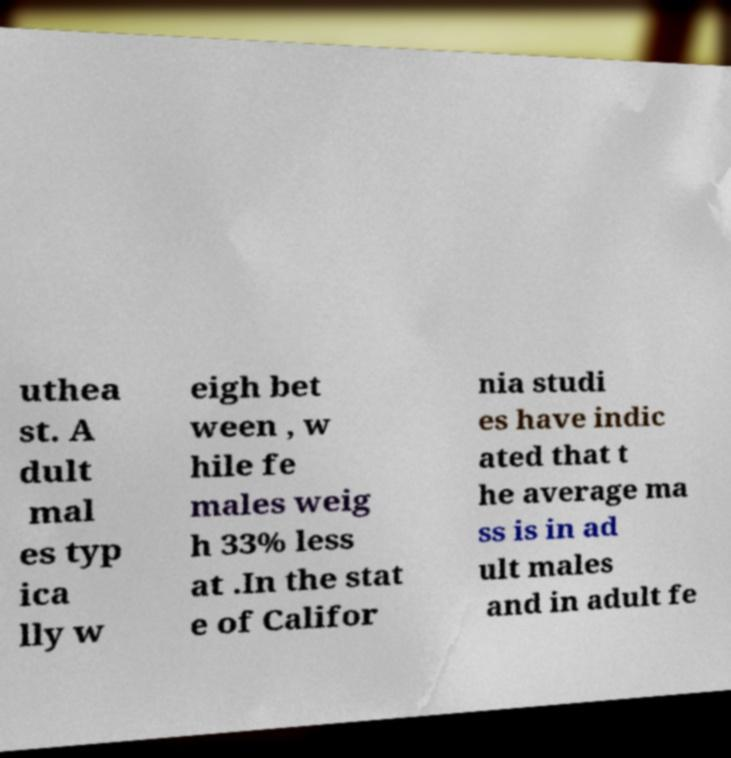What messages or text are displayed in this image? I need them in a readable, typed format. uthea st. A dult mal es typ ica lly w eigh bet ween , w hile fe males weig h 33% less at .In the stat e of Califor nia studi es have indic ated that t he average ma ss is in ad ult males and in adult fe 